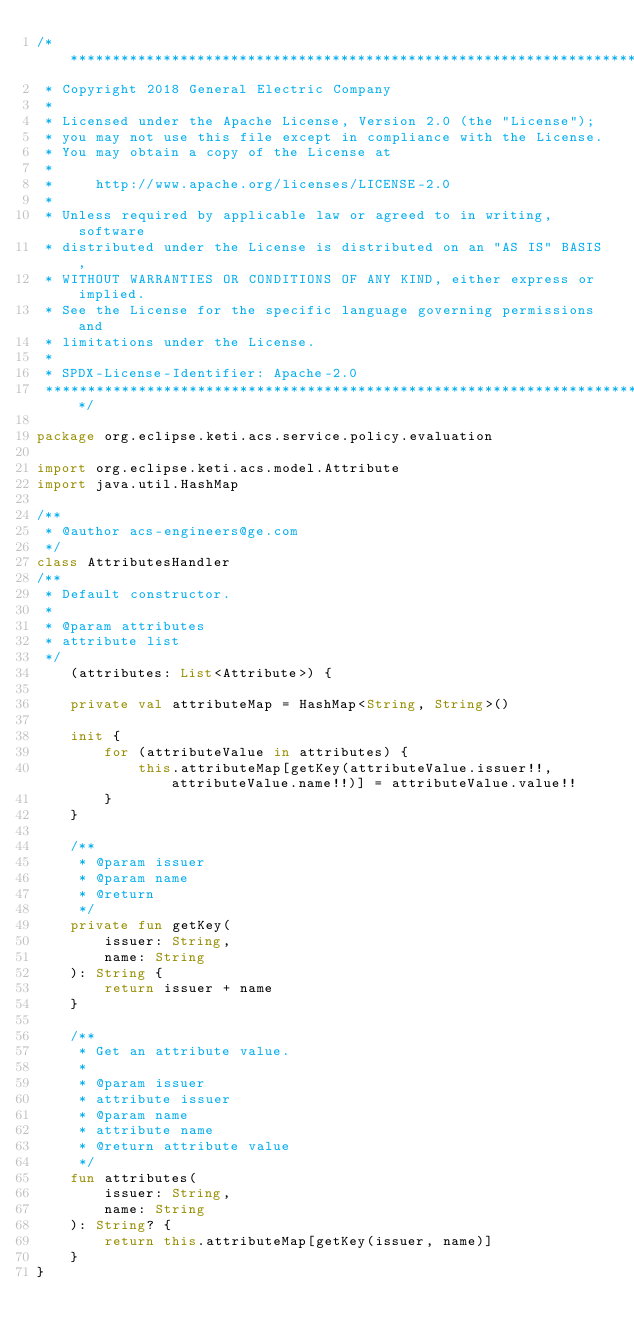<code> <loc_0><loc_0><loc_500><loc_500><_Kotlin_>/*******************************************************************************
 * Copyright 2018 General Electric Company
 *
 * Licensed under the Apache License, Version 2.0 (the "License");
 * you may not use this file except in compliance with the License.
 * You may obtain a copy of the License at
 *
 *     http://www.apache.org/licenses/LICENSE-2.0
 *
 * Unless required by applicable law or agreed to in writing, software
 * distributed under the License is distributed on an "AS IS" BASIS,
 * WITHOUT WARRANTIES OR CONDITIONS OF ANY KIND, either express or implied.
 * See the License for the specific language governing permissions and
 * limitations under the License.
 *
 * SPDX-License-Identifier: Apache-2.0
 *******************************************************************************/

package org.eclipse.keti.acs.service.policy.evaluation

import org.eclipse.keti.acs.model.Attribute
import java.util.HashMap

/**
 * @author acs-engineers@ge.com
 */
class AttributesHandler
/**
 * Default constructor.
 *
 * @param attributes
 * attribute list
 */
    (attributes: List<Attribute>) {

    private val attributeMap = HashMap<String, String>()

    init {
        for (attributeValue in attributes) {
            this.attributeMap[getKey(attributeValue.issuer!!, attributeValue.name!!)] = attributeValue.value!!
        }
    }

    /**
     * @param issuer
     * @param name
     * @return
     */
    private fun getKey(
        issuer: String,
        name: String
    ): String {
        return issuer + name
    }

    /**
     * Get an attribute value.
     *
     * @param issuer
     * attribute issuer
     * @param name
     * attribute name
     * @return attribute value
     */
    fun attributes(
        issuer: String,
        name: String
    ): String? {
        return this.attributeMap[getKey(issuer, name)]
    }
}
</code> 